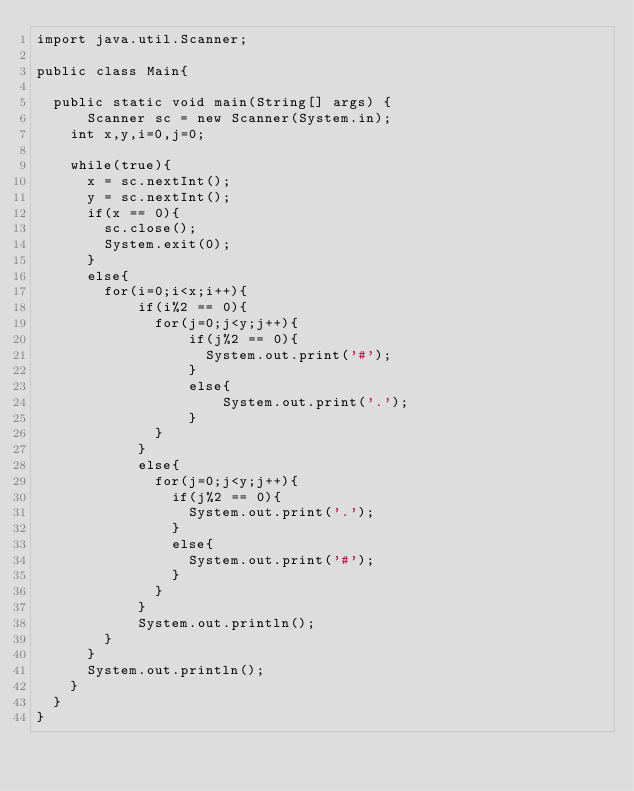<code> <loc_0><loc_0><loc_500><loc_500><_Java_>import java.util.Scanner;

public class Main{

	public static void main(String[] args) {
	    Scanner sc = new Scanner(System.in);
		int x,y,i=0,j=0;
		
		while(true){
			x = sc.nextInt();
			y = sc.nextInt();
			if(x == 0){
				sc.close();
				System.exit(0);
			}
			else{
				for(i=0;i<x;i++){
				    if(i%2 == 0){
				    	for(j=0;j<y;j++){
				    	    if(j%2 == 0){
				    		    System.out.print('#');
				    	    }
				    	    else{
				    	        System.out.print('.');
				    	    }
				    	}
				    }
				    else{
				    	for(j=0;j<y;j++){
				    		if(j%2 == 0){
				    			System.out.print('.');
				    		}
				    		else{
				    			System.out.print('#');
				    		}
				    	}
				    }
				    System.out.println();
				}
			}
			System.out.println();
		}
	}
}
</code> 